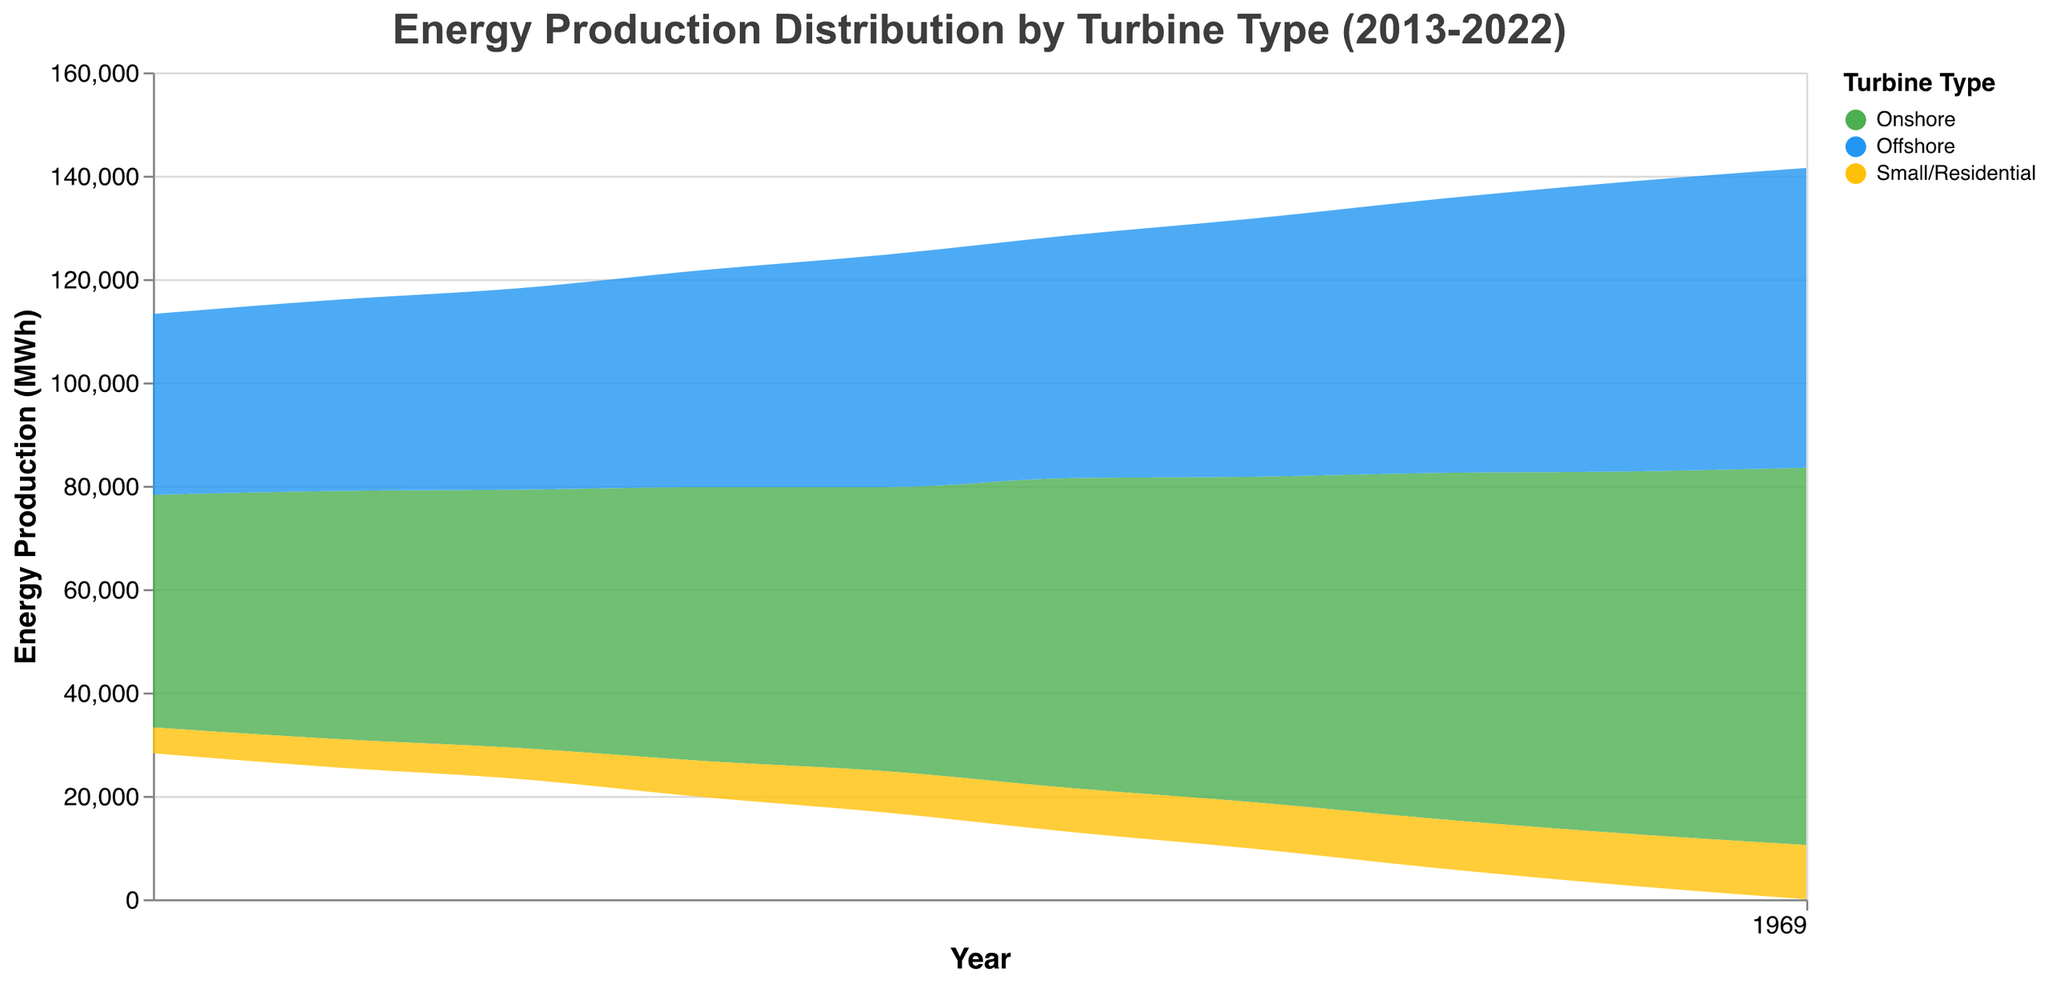What's the title of the figure? The title of the figure is typically displayed at the top center and describes the data being shown. In this case, the title is provided in the "title" field of the code.
Answer: Energy Production Distribution by Turbine Type (2013-2022) How many turbine types are shown in the figure? We can identify the different turbine types represented by the colors in the chart and the legend. There are three labels listed under "domain" in the code and described in different colors.
Answer: Three Which year had the highest total energy production? To determine the year with the highest total energy production, we add the energy production of all turbine types for each year and compare them. 2022: 73000 + 58000 + 10500 = 141500; 2021: 70000 + 56000 + 10000 = 136000; etc.
Answer: 2022 By how much did the energy production of onshore turbines increase from 2013 to 2022? Subtract the energy production of onshore turbines in 2013 from that in 2022. 73000 (2022) - 45000 (2013) = 28000.
Answer: 28000 MWh Which turbine type had the least contribution to energy production in 2020? We compare the energy production figures of different turbine types for 2020 and identify the smallest value. Small/Residential: 9500; Offshore: 53000; Onshore: 67000.
Answer: Small/Residential How did the distribution of energy production between offshore and small/residential turbines change from 2017 to 2018? To answer this, compare the energy production values for these two turbine types between 2017 and 2018. Offshore: 45000 (2017) to 47000 (2018); Small/Residential: 8000 (2017) to 8500 (2018). Create a ratio or difference for each comparison.
Answer: Both increased, Offshore by 2000 MWh and Small/Residential by 500 MWh What is the difference in energy production between onshore and offshore turbines in 2022? Subtract the energy production for offshore turbines from that of onshore turbines for the year 2022. 73000 (Onshore) - 58000 (Offshore) = 15000.
Answer: 15000 MWh Which turbine type shows the most consistent increase in energy production over the years? Calculate the yearly increase for each turbine type and see which one rises steadily. By visually inspecting the graph and data values, Onshore turbines show the most steady and consistent yearly increase.
Answer: Onshore What's the overall trend in energy production from small/residential turbines from 2013 to 2022? Review the values for small/residential turbines every year between 2013 and 2022. Notice the increase from 5000 MWh in 2013 to 10500 MWh in 2022, indicating a consistent upward trend.
Answer: Consistent increase 